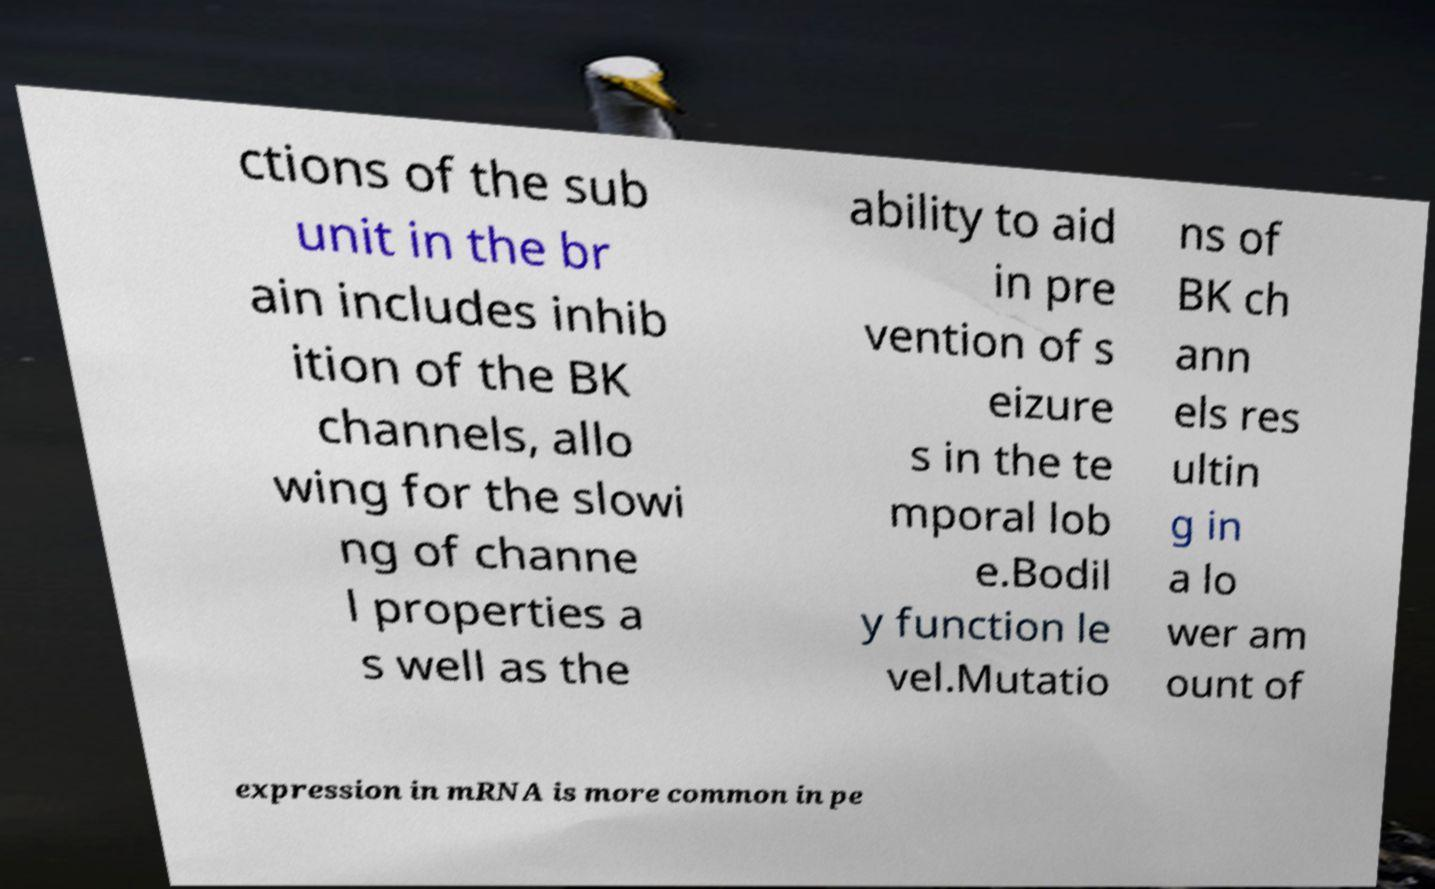Could you assist in decoding the text presented in this image and type it out clearly? ctions of the sub unit in the br ain includes inhib ition of the BK channels, allo wing for the slowi ng of channe l properties a s well as the ability to aid in pre vention of s eizure s in the te mporal lob e.Bodil y function le vel.Mutatio ns of BK ch ann els res ultin g in a lo wer am ount of expression in mRNA is more common in pe 